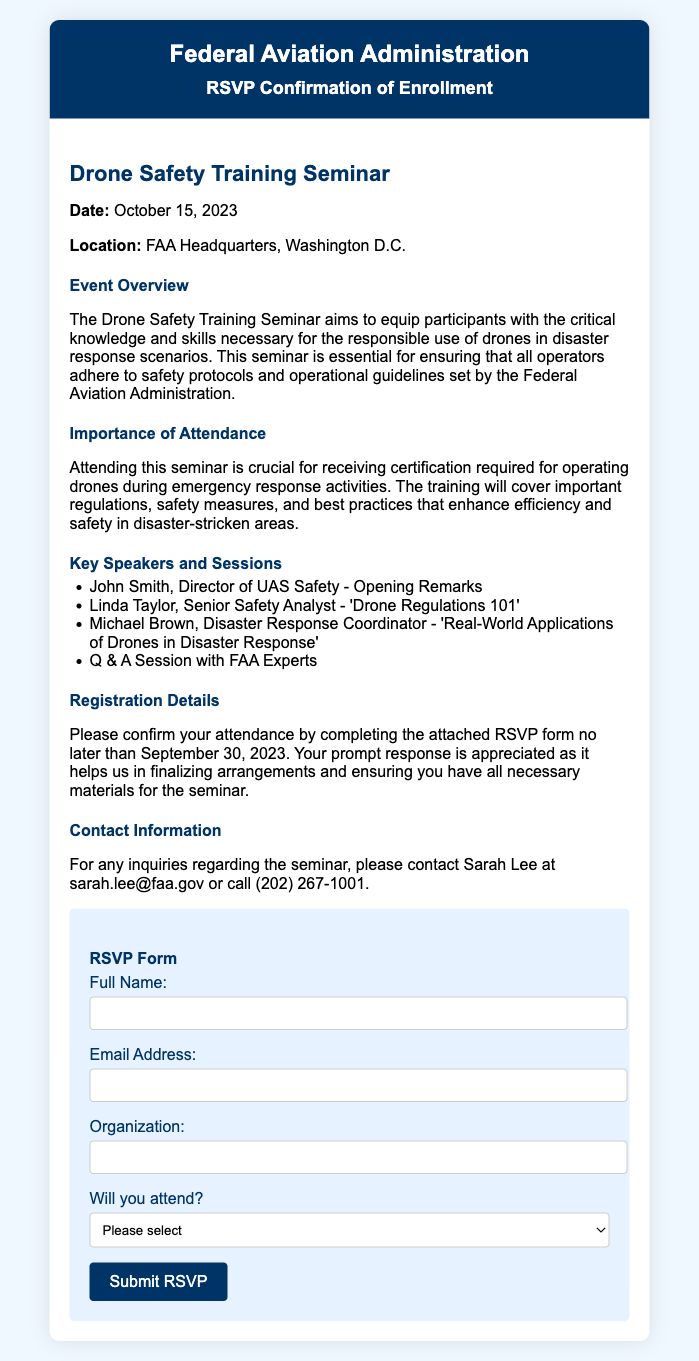What is the date of the seminar? The date of the seminar is specified in the event details section of the document.
Answer: October 15, 2023 Where is the seminar taking place? The location of the seminar is mentioned in the event details section.
Answer: FAA Headquarters, Washington D.C Who is the opening speaker? The opening speaker is listed under the key speakers and sessions section of the document.
Answer: John Smith What is the deadline for confirming attendance? The deadline for confirming attendance is mentioned in the registration details section of the document.
Answer: September 30, 2023 What is the main purpose of the seminar? The main purpose is described in the event overview section, focusing on equipping participants with knowledge and skills.
Answer: Responsible use of drones in disaster response What type of certification is received from attending? The type of certification is indicated as necessary for operations during emergency response activities.
Answer: Certification for operating drones What contact information is provided for inquiries? The contact information includes the name and email of the person responsible for inquiries.
Answer: Sarah Lee at sarah.lee@faa.gov Will attendees be able to ask questions? The inclusion of a specific session indicates opportunities for engagement with speakers.
Answer: Yes, during Q & A Session What do attendees need to complete to confirm their attendance? The RSVP process is clearly indicated in the document, specifying what is required from participants.
Answer: Complete the attached RSVP form 